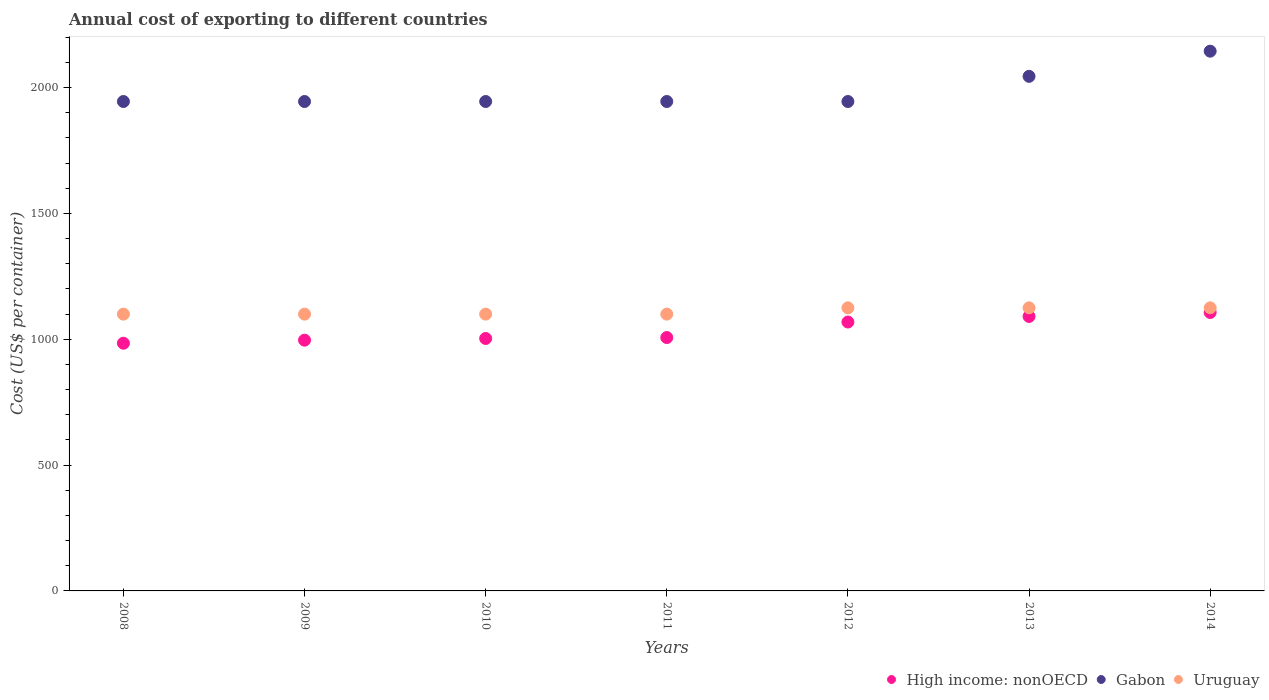Is the number of dotlines equal to the number of legend labels?
Your answer should be compact. Yes. What is the total annual cost of exporting in High income: nonOECD in 2010?
Provide a succinct answer. 1003.24. Across all years, what is the maximum total annual cost of exporting in High income: nonOECD?
Your response must be concise. 1106.62. Across all years, what is the minimum total annual cost of exporting in Uruguay?
Your answer should be very brief. 1100. What is the total total annual cost of exporting in High income: nonOECD in the graph?
Make the answer very short. 7257.19. What is the difference between the total annual cost of exporting in Uruguay in 2010 and that in 2013?
Offer a very short reply. -25. What is the difference between the total annual cost of exporting in High income: nonOECD in 2011 and the total annual cost of exporting in Gabon in 2012?
Offer a very short reply. -938.04. What is the average total annual cost of exporting in High income: nonOECD per year?
Give a very brief answer. 1036.74. In the year 2012, what is the difference between the total annual cost of exporting in High income: nonOECD and total annual cost of exporting in Gabon?
Keep it short and to the point. -876.36. In how many years, is the total annual cost of exporting in Uruguay greater than 2000 US$?
Give a very brief answer. 0. What is the ratio of the total annual cost of exporting in Gabon in 2008 to that in 2014?
Offer a very short reply. 0.91. What is the difference between the highest and the second highest total annual cost of exporting in High income: nonOECD?
Keep it short and to the point. 15.82. What is the difference between the highest and the lowest total annual cost of exporting in Uruguay?
Offer a terse response. 25. Is the sum of the total annual cost of exporting in Gabon in 2009 and 2010 greater than the maximum total annual cost of exporting in Uruguay across all years?
Ensure brevity in your answer.  Yes. Does the total annual cost of exporting in Uruguay monotonically increase over the years?
Keep it short and to the point. No. Is the total annual cost of exporting in High income: nonOECD strictly less than the total annual cost of exporting in Gabon over the years?
Provide a succinct answer. Yes. How many dotlines are there?
Offer a very short reply. 3. Are the values on the major ticks of Y-axis written in scientific E-notation?
Provide a short and direct response. No. Does the graph contain grids?
Keep it short and to the point. No. Where does the legend appear in the graph?
Make the answer very short. Bottom right. How are the legend labels stacked?
Provide a succinct answer. Horizontal. What is the title of the graph?
Give a very brief answer. Annual cost of exporting to different countries. What is the label or title of the Y-axis?
Provide a short and direct response. Cost (US$ per container). What is the Cost (US$ per container) in High income: nonOECD in 2008?
Provide a succinct answer. 984.4. What is the Cost (US$ per container) of Gabon in 2008?
Your answer should be compact. 1945. What is the Cost (US$ per container) in Uruguay in 2008?
Your answer should be compact. 1100. What is the Cost (US$ per container) of High income: nonOECD in 2009?
Offer a very short reply. 996.52. What is the Cost (US$ per container) in Gabon in 2009?
Give a very brief answer. 1945. What is the Cost (US$ per container) in Uruguay in 2009?
Make the answer very short. 1100. What is the Cost (US$ per container) in High income: nonOECD in 2010?
Offer a very short reply. 1003.24. What is the Cost (US$ per container) in Gabon in 2010?
Your answer should be very brief. 1945. What is the Cost (US$ per container) in Uruguay in 2010?
Your answer should be very brief. 1100. What is the Cost (US$ per container) of High income: nonOECD in 2011?
Your answer should be very brief. 1006.96. What is the Cost (US$ per container) in Gabon in 2011?
Keep it short and to the point. 1945. What is the Cost (US$ per container) in Uruguay in 2011?
Keep it short and to the point. 1100. What is the Cost (US$ per container) of High income: nonOECD in 2012?
Give a very brief answer. 1068.64. What is the Cost (US$ per container) of Gabon in 2012?
Provide a short and direct response. 1945. What is the Cost (US$ per container) in Uruguay in 2012?
Offer a very short reply. 1125. What is the Cost (US$ per container) of High income: nonOECD in 2013?
Keep it short and to the point. 1090.8. What is the Cost (US$ per container) of Gabon in 2013?
Your response must be concise. 2045. What is the Cost (US$ per container) of Uruguay in 2013?
Provide a short and direct response. 1125. What is the Cost (US$ per container) in High income: nonOECD in 2014?
Provide a succinct answer. 1106.62. What is the Cost (US$ per container) of Gabon in 2014?
Give a very brief answer. 2145. What is the Cost (US$ per container) in Uruguay in 2014?
Your answer should be very brief. 1125. Across all years, what is the maximum Cost (US$ per container) of High income: nonOECD?
Provide a succinct answer. 1106.62. Across all years, what is the maximum Cost (US$ per container) in Gabon?
Keep it short and to the point. 2145. Across all years, what is the maximum Cost (US$ per container) in Uruguay?
Ensure brevity in your answer.  1125. Across all years, what is the minimum Cost (US$ per container) in High income: nonOECD?
Offer a terse response. 984.4. Across all years, what is the minimum Cost (US$ per container) in Gabon?
Ensure brevity in your answer.  1945. Across all years, what is the minimum Cost (US$ per container) in Uruguay?
Your answer should be compact. 1100. What is the total Cost (US$ per container) in High income: nonOECD in the graph?
Your answer should be compact. 7257.19. What is the total Cost (US$ per container) in Gabon in the graph?
Your answer should be compact. 1.39e+04. What is the total Cost (US$ per container) in Uruguay in the graph?
Your answer should be compact. 7775. What is the difference between the Cost (US$ per container) of High income: nonOECD in 2008 and that in 2009?
Your answer should be very brief. -12.12. What is the difference between the Cost (US$ per container) of Gabon in 2008 and that in 2009?
Provide a short and direct response. 0. What is the difference between the Cost (US$ per container) of High income: nonOECD in 2008 and that in 2010?
Offer a very short reply. -18.84. What is the difference between the Cost (US$ per container) in Uruguay in 2008 and that in 2010?
Provide a short and direct response. 0. What is the difference between the Cost (US$ per container) in High income: nonOECD in 2008 and that in 2011?
Your response must be concise. -22.56. What is the difference between the Cost (US$ per container) in Uruguay in 2008 and that in 2011?
Make the answer very short. 0. What is the difference between the Cost (US$ per container) of High income: nonOECD in 2008 and that in 2012?
Provide a short and direct response. -84.24. What is the difference between the Cost (US$ per container) of Gabon in 2008 and that in 2012?
Provide a succinct answer. 0. What is the difference between the Cost (US$ per container) in Uruguay in 2008 and that in 2012?
Ensure brevity in your answer.  -25. What is the difference between the Cost (US$ per container) in High income: nonOECD in 2008 and that in 2013?
Your answer should be very brief. -106.4. What is the difference between the Cost (US$ per container) in Gabon in 2008 and that in 2013?
Your response must be concise. -100. What is the difference between the Cost (US$ per container) of Uruguay in 2008 and that in 2013?
Your answer should be very brief. -25. What is the difference between the Cost (US$ per container) of High income: nonOECD in 2008 and that in 2014?
Offer a very short reply. -122.22. What is the difference between the Cost (US$ per container) in Gabon in 2008 and that in 2014?
Your response must be concise. -200. What is the difference between the Cost (US$ per container) in Uruguay in 2008 and that in 2014?
Your response must be concise. -25. What is the difference between the Cost (US$ per container) of High income: nonOECD in 2009 and that in 2010?
Offer a terse response. -6.72. What is the difference between the Cost (US$ per container) of Gabon in 2009 and that in 2010?
Ensure brevity in your answer.  0. What is the difference between the Cost (US$ per container) of Uruguay in 2009 and that in 2010?
Your response must be concise. 0. What is the difference between the Cost (US$ per container) in High income: nonOECD in 2009 and that in 2011?
Your response must be concise. -10.44. What is the difference between the Cost (US$ per container) of Gabon in 2009 and that in 2011?
Ensure brevity in your answer.  0. What is the difference between the Cost (US$ per container) of Uruguay in 2009 and that in 2011?
Make the answer very short. 0. What is the difference between the Cost (US$ per container) in High income: nonOECD in 2009 and that in 2012?
Offer a very short reply. -72.12. What is the difference between the Cost (US$ per container) of Uruguay in 2009 and that in 2012?
Give a very brief answer. -25. What is the difference between the Cost (US$ per container) of High income: nonOECD in 2009 and that in 2013?
Ensure brevity in your answer.  -94.28. What is the difference between the Cost (US$ per container) of Gabon in 2009 and that in 2013?
Give a very brief answer. -100. What is the difference between the Cost (US$ per container) of High income: nonOECD in 2009 and that in 2014?
Provide a short and direct response. -110.11. What is the difference between the Cost (US$ per container) of Gabon in 2009 and that in 2014?
Ensure brevity in your answer.  -200. What is the difference between the Cost (US$ per container) in Uruguay in 2009 and that in 2014?
Your response must be concise. -25. What is the difference between the Cost (US$ per container) in High income: nonOECD in 2010 and that in 2011?
Make the answer very short. -3.72. What is the difference between the Cost (US$ per container) in Gabon in 2010 and that in 2011?
Your response must be concise. 0. What is the difference between the Cost (US$ per container) in High income: nonOECD in 2010 and that in 2012?
Give a very brief answer. -65.4. What is the difference between the Cost (US$ per container) in Gabon in 2010 and that in 2012?
Your answer should be compact. 0. What is the difference between the Cost (US$ per container) in High income: nonOECD in 2010 and that in 2013?
Offer a very short reply. -87.56. What is the difference between the Cost (US$ per container) in Gabon in 2010 and that in 2013?
Keep it short and to the point. -100. What is the difference between the Cost (US$ per container) in High income: nonOECD in 2010 and that in 2014?
Your answer should be very brief. -103.39. What is the difference between the Cost (US$ per container) in Gabon in 2010 and that in 2014?
Your response must be concise. -200. What is the difference between the Cost (US$ per container) in High income: nonOECD in 2011 and that in 2012?
Provide a short and direct response. -61.68. What is the difference between the Cost (US$ per container) in Gabon in 2011 and that in 2012?
Provide a succinct answer. 0. What is the difference between the Cost (US$ per container) in High income: nonOECD in 2011 and that in 2013?
Offer a very short reply. -83.84. What is the difference between the Cost (US$ per container) in Gabon in 2011 and that in 2013?
Provide a succinct answer. -100. What is the difference between the Cost (US$ per container) of Uruguay in 2011 and that in 2013?
Keep it short and to the point. -25. What is the difference between the Cost (US$ per container) in High income: nonOECD in 2011 and that in 2014?
Ensure brevity in your answer.  -99.66. What is the difference between the Cost (US$ per container) in Gabon in 2011 and that in 2014?
Provide a short and direct response. -200. What is the difference between the Cost (US$ per container) in High income: nonOECD in 2012 and that in 2013?
Ensure brevity in your answer.  -22.16. What is the difference between the Cost (US$ per container) of Gabon in 2012 and that in 2013?
Your response must be concise. -100. What is the difference between the Cost (US$ per container) in Uruguay in 2012 and that in 2013?
Keep it short and to the point. 0. What is the difference between the Cost (US$ per container) in High income: nonOECD in 2012 and that in 2014?
Ensure brevity in your answer.  -37.98. What is the difference between the Cost (US$ per container) in Gabon in 2012 and that in 2014?
Offer a very short reply. -200. What is the difference between the Cost (US$ per container) in Uruguay in 2012 and that in 2014?
Keep it short and to the point. 0. What is the difference between the Cost (US$ per container) of High income: nonOECD in 2013 and that in 2014?
Give a very brief answer. -15.82. What is the difference between the Cost (US$ per container) of Gabon in 2013 and that in 2014?
Provide a short and direct response. -100. What is the difference between the Cost (US$ per container) in High income: nonOECD in 2008 and the Cost (US$ per container) in Gabon in 2009?
Your answer should be compact. -960.6. What is the difference between the Cost (US$ per container) in High income: nonOECD in 2008 and the Cost (US$ per container) in Uruguay in 2009?
Ensure brevity in your answer.  -115.6. What is the difference between the Cost (US$ per container) in Gabon in 2008 and the Cost (US$ per container) in Uruguay in 2009?
Provide a succinct answer. 845. What is the difference between the Cost (US$ per container) of High income: nonOECD in 2008 and the Cost (US$ per container) of Gabon in 2010?
Offer a terse response. -960.6. What is the difference between the Cost (US$ per container) in High income: nonOECD in 2008 and the Cost (US$ per container) in Uruguay in 2010?
Give a very brief answer. -115.6. What is the difference between the Cost (US$ per container) of Gabon in 2008 and the Cost (US$ per container) of Uruguay in 2010?
Provide a succinct answer. 845. What is the difference between the Cost (US$ per container) of High income: nonOECD in 2008 and the Cost (US$ per container) of Gabon in 2011?
Ensure brevity in your answer.  -960.6. What is the difference between the Cost (US$ per container) in High income: nonOECD in 2008 and the Cost (US$ per container) in Uruguay in 2011?
Give a very brief answer. -115.6. What is the difference between the Cost (US$ per container) in Gabon in 2008 and the Cost (US$ per container) in Uruguay in 2011?
Make the answer very short. 845. What is the difference between the Cost (US$ per container) of High income: nonOECD in 2008 and the Cost (US$ per container) of Gabon in 2012?
Keep it short and to the point. -960.6. What is the difference between the Cost (US$ per container) of High income: nonOECD in 2008 and the Cost (US$ per container) of Uruguay in 2012?
Offer a very short reply. -140.6. What is the difference between the Cost (US$ per container) of Gabon in 2008 and the Cost (US$ per container) of Uruguay in 2012?
Your answer should be compact. 820. What is the difference between the Cost (US$ per container) of High income: nonOECD in 2008 and the Cost (US$ per container) of Gabon in 2013?
Provide a short and direct response. -1060.6. What is the difference between the Cost (US$ per container) in High income: nonOECD in 2008 and the Cost (US$ per container) in Uruguay in 2013?
Your answer should be compact. -140.6. What is the difference between the Cost (US$ per container) in Gabon in 2008 and the Cost (US$ per container) in Uruguay in 2013?
Your answer should be compact. 820. What is the difference between the Cost (US$ per container) of High income: nonOECD in 2008 and the Cost (US$ per container) of Gabon in 2014?
Provide a succinct answer. -1160.6. What is the difference between the Cost (US$ per container) of High income: nonOECD in 2008 and the Cost (US$ per container) of Uruguay in 2014?
Make the answer very short. -140.6. What is the difference between the Cost (US$ per container) in Gabon in 2008 and the Cost (US$ per container) in Uruguay in 2014?
Offer a terse response. 820. What is the difference between the Cost (US$ per container) in High income: nonOECD in 2009 and the Cost (US$ per container) in Gabon in 2010?
Offer a very short reply. -948.48. What is the difference between the Cost (US$ per container) of High income: nonOECD in 2009 and the Cost (US$ per container) of Uruguay in 2010?
Ensure brevity in your answer.  -103.48. What is the difference between the Cost (US$ per container) in Gabon in 2009 and the Cost (US$ per container) in Uruguay in 2010?
Keep it short and to the point. 845. What is the difference between the Cost (US$ per container) in High income: nonOECD in 2009 and the Cost (US$ per container) in Gabon in 2011?
Your response must be concise. -948.48. What is the difference between the Cost (US$ per container) of High income: nonOECD in 2009 and the Cost (US$ per container) of Uruguay in 2011?
Your answer should be compact. -103.48. What is the difference between the Cost (US$ per container) in Gabon in 2009 and the Cost (US$ per container) in Uruguay in 2011?
Your response must be concise. 845. What is the difference between the Cost (US$ per container) in High income: nonOECD in 2009 and the Cost (US$ per container) in Gabon in 2012?
Provide a succinct answer. -948.48. What is the difference between the Cost (US$ per container) of High income: nonOECD in 2009 and the Cost (US$ per container) of Uruguay in 2012?
Keep it short and to the point. -128.48. What is the difference between the Cost (US$ per container) in Gabon in 2009 and the Cost (US$ per container) in Uruguay in 2012?
Provide a short and direct response. 820. What is the difference between the Cost (US$ per container) of High income: nonOECD in 2009 and the Cost (US$ per container) of Gabon in 2013?
Provide a short and direct response. -1048.48. What is the difference between the Cost (US$ per container) in High income: nonOECD in 2009 and the Cost (US$ per container) in Uruguay in 2013?
Provide a short and direct response. -128.48. What is the difference between the Cost (US$ per container) in Gabon in 2009 and the Cost (US$ per container) in Uruguay in 2013?
Your answer should be very brief. 820. What is the difference between the Cost (US$ per container) in High income: nonOECD in 2009 and the Cost (US$ per container) in Gabon in 2014?
Offer a terse response. -1148.48. What is the difference between the Cost (US$ per container) of High income: nonOECD in 2009 and the Cost (US$ per container) of Uruguay in 2014?
Offer a very short reply. -128.48. What is the difference between the Cost (US$ per container) in Gabon in 2009 and the Cost (US$ per container) in Uruguay in 2014?
Make the answer very short. 820. What is the difference between the Cost (US$ per container) of High income: nonOECD in 2010 and the Cost (US$ per container) of Gabon in 2011?
Provide a succinct answer. -941.76. What is the difference between the Cost (US$ per container) in High income: nonOECD in 2010 and the Cost (US$ per container) in Uruguay in 2011?
Offer a very short reply. -96.76. What is the difference between the Cost (US$ per container) of Gabon in 2010 and the Cost (US$ per container) of Uruguay in 2011?
Your response must be concise. 845. What is the difference between the Cost (US$ per container) in High income: nonOECD in 2010 and the Cost (US$ per container) in Gabon in 2012?
Offer a terse response. -941.76. What is the difference between the Cost (US$ per container) of High income: nonOECD in 2010 and the Cost (US$ per container) of Uruguay in 2012?
Provide a succinct answer. -121.76. What is the difference between the Cost (US$ per container) of Gabon in 2010 and the Cost (US$ per container) of Uruguay in 2012?
Give a very brief answer. 820. What is the difference between the Cost (US$ per container) of High income: nonOECD in 2010 and the Cost (US$ per container) of Gabon in 2013?
Your answer should be very brief. -1041.76. What is the difference between the Cost (US$ per container) of High income: nonOECD in 2010 and the Cost (US$ per container) of Uruguay in 2013?
Your answer should be compact. -121.76. What is the difference between the Cost (US$ per container) of Gabon in 2010 and the Cost (US$ per container) of Uruguay in 2013?
Keep it short and to the point. 820. What is the difference between the Cost (US$ per container) in High income: nonOECD in 2010 and the Cost (US$ per container) in Gabon in 2014?
Give a very brief answer. -1141.76. What is the difference between the Cost (US$ per container) of High income: nonOECD in 2010 and the Cost (US$ per container) of Uruguay in 2014?
Keep it short and to the point. -121.76. What is the difference between the Cost (US$ per container) of Gabon in 2010 and the Cost (US$ per container) of Uruguay in 2014?
Your answer should be very brief. 820. What is the difference between the Cost (US$ per container) of High income: nonOECD in 2011 and the Cost (US$ per container) of Gabon in 2012?
Give a very brief answer. -938.04. What is the difference between the Cost (US$ per container) in High income: nonOECD in 2011 and the Cost (US$ per container) in Uruguay in 2012?
Your answer should be compact. -118.04. What is the difference between the Cost (US$ per container) of Gabon in 2011 and the Cost (US$ per container) of Uruguay in 2012?
Give a very brief answer. 820. What is the difference between the Cost (US$ per container) in High income: nonOECD in 2011 and the Cost (US$ per container) in Gabon in 2013?
Your answer should be very brief. -1038.04. What is the difference between the Cost (US$ per container) in High income: nonOECD in 2011 and the Cost (US$ per container) in Uruguay in 2013?
Your answer should be very brief. -118.04. What is the difference between the Cost (US$ per container) in Gabon in 2011 and the Cost (US$ per container) in Uruguay in 2013?
Make the answer very short. 820. What is the difference between the Cost (US$ per container) of High income: nonOECD in 2011 and the Cost (US$ per container) of Gabon in 2014?
Offer a terse response. -1138.04. What is the difference between the Cost (US$ per container) of High income: nonOECD in 2011 and the Cost (US$ per container) of Uruguay in 2014?
Make the answer very short. -118.04. What is the difference between the Cost (US$ per container) of Gabon in 2011 and the Cost (US$ per container) of Uruguay in 2014?
Ensure brevity in your answer.  820. What is the difference between the Cost (US$ per container) of High income: nonOECD in 2012 and the Cost (US$ per container) of Gabon in 2013?
Ensure brevity in your answer.  -976.36. What is the difference between the Cost (US$ per container) in High income: nonOECD in 2012 and the Cost (US$ per container) in Uruguay in 2013?
Make the answer very short. -56.36. What is the difference between the Cost (US$ per container) of Gabon in 2012 and the Cost (US$ per container) of Uruguay in 2013?
Your answer should be compact. 820. What is the difference between the Cost (US$ per container) of High income: nonOECD in 2012 and the Cost (US$ per container) of Gabon in 2014?
Keep it short and to the point. -1076.36. What is the difference between the Cost (US$ per container) in High income: nonOECD in 2012 and the Cost (US$ per container) in Uruguay in 2014?
Offer a terse response. -56.36. What is the difference between the Cost (US$ per container) of Gabon in 2012 and the Cost (US$ per container) of Uruguay in 2014?
Offer a terse response. 820. What is the difference between the Cost (US$ per container) of High income: nonOECD in 2013 and the Cost (US$ per container) of Gabon in 2014?
Your answer should be compact. -1054.2. What is the difference between the Cost (US$ per container) in High income: nonOECD in 2013 and the Cost (US$ per container) in Uruguay in 2014?
Provide a short and direct response. -34.2. What is the difference between the Cost (US$ per container) in Gabon in 2013 and the Cost (US$ per container) in Uruguay in 2014?
Offer a very short reply. 920. What is the average Cost (US$ per container) of High income: nonOECD per year?
Give a very brief answer. 1036.74. What is the average Cost (US$ per container) of Gabon per year?
Offer a very short reply. 1987.86. What is the average Cost (US$ per container) of Uruguay per year?
Keep it short and to the point. 1110.71. In the year 2008, what is the difference between the Cost (US$ per container) of High income: nonOECD and Cost (US$ per container) of Gabon?
Keep it short and to the point. -960.6. In the year 2008, what is the difference between the Cost (US$ per container) in High income: nonOECD and Cost (US$ per container) in Uruguay?
Your answer should be very brief. -115.6. In the year 2008, what is the difference between the Cost (US$ per container) in Gabon and Cost (US$ per container) in Uruguay?
Provide a succinct answer. 845. In the year 2009, what is the difference between the Cost (US$ per container) of High income: nonOECD and Cost (US$ per container) of Gabon?
Offer a very short reply. -948.48. In the year 2009, what is the difference between the Cost (US$ per container) of High income: nonOECD and Cost (US$ per container) of Uruguay?
Keep it short and to the point. -103.48. In the year 2009, what is the difference between the Cost (US$ per container) of Gabon and Cost (US$ per container) of Uruguay?
Keep it short and to the point. 845. In the year 2010, what is the difference between the Cost (US$ per container) of High income: nonOECD and Cost (US$ per container) of Gabon?
Ensure brevity in your answer.  -941.76. In the year 2010, what is the difference between the Cost (US$ per container) in High income: nonOECD and Cost (US$ per container) in Uruguay?
Give a very brief answer. -96.76. In the year 2010, what is the difference between the Cost (US$ per container) of Gabon and Cost (US$ per container) of Uruguay?
Provide a succinct answer. 845. In the year 2011, what is the difference between the Cost (US$ per container) of High income: nonOECD and Cost (US$ per container) of Gabon?
Your answer should be very brief. -938.04. In the year 2011, what is the difference between the Cost (US$ per container) of High income: nonOECD and Cost (US$ per container) of Uruguay?
Make the answer very short. -93.04. In the year 2011, what is the difference between the Cost (US$ per container) in Gabon and Cost (US$ per container) in Uruguay?
Your answer should be compact. 845. In the year 2012, what is the difference between the Cost (US$ per container) in High income: nonOECD and Cost (US$ per container) in Gabon?
Your answer should be compact. -876.36. In the year 2012, what is the difference between the Cost (US$ per container) in High income: nonOECD and Cost (US$ per container) in Uruguay?
Keep it short and to the point. -56.36. In the year 2012, what is the difference between the Cost (US$ per container) of Gabon and Cost (US$ per container) of Uruguay?
Keep it short and to the point. 820. In the year 2013, what is the difference between the Cost (US$ per container) of High income: nonOECD and Cost (US$ per container) of Gabon?
Your answer should be very brief. -954.2. In the year 2013, what is the difference between the Cost (US$ per container) in High income: nonOECD and Cost (US$ per container) in Uruguay?
Provide a succinct answer. -34.2. In the year 2013, what is the difference between the Cost (US$ per container) of Gabon and Cost (US$ per container) of Uruguay?
Provide a succinct answer. 920. In the year 2014, what is the difference between the Cost (US$ per container) of High income: nonOECD and Cost (US$ per container) of Gabon?
Offer a very short reply. -1038.38. In the year 2014, what is the difference between the Cost (US$ per container) in High income: nonOECD and Cost (US$ per container) in Uruguay?
Your answer should be compact. -18.38. In the year 2014, what is the difference between the Cost (US$ per container) in Gabon and Cost (US$ per container) in Uruguay?
Make the answer very short. 1020. What is the ratio of the Cost (US$ per container) in Gabon in 2008 to that in 2009?
Keep it short and to the point. 1. What is the ratio of the Cost (US$ per container) of Uruguay in 2008 to that in 2009?
Your answer should be compact. 1. What is the ratio of the Cost (US$ per container) of High income: nonOECD in 2008 to that in 2010?
Keep it short and to the point. 0.98. What is the ratio of the Cost (US$ per container) in Uruguay in 2008 to that in 2010?
Keep it short and to the point. 1. What is the ratio of the Cost (US$ per container) in High income: nonOECD in 2008 to that in 2011?
Keep it short and to the point. 0.98. What is the ratio of the Cost (US$ per container) of Gabon in 2008 to that in 2011?
Your answer should be very brief. 1. What is the ratio of the Cost (US$ per container) in High income: nonOECD in 2008 to that in 2012?
Your answer should be compact. 0.92. What is the ratio of the Cost (US$ per container) in Uruguay in 2008 to that in 2012?
Offer a very short reply. 0.98. What is the ratio of the Cost (US$ per container) of High income: nonOECD in 2008 to that in 2013?
Make the answer very short. 0.9. What is the ratio of the Cost (US$ per container) of Gabon in 2008 to that in 2013?
Offer a very short reply. 0.95. What is the ratio of the Cost (US$ per container) in Uruguay in 2008 to that in 2013?
Give a very brief answer. 0.98. What is the ratio of the Cost (US$ per container) of High income: nonOECD in 2008 to that in 2014?
Make the answer very short. 0.89. What is the ratio of the Cost (US$ per container) of Gabon in 2008 to that in 2014?
Ensure brevity in your answer.  0.91. What is the ratio of the Cost (US$ per container) in Uruguay in 2008 to that in 2014?
Provide a succinct answer. 0.98. What is the ratio of the Cost (US$ per container) of High income: nonOECD in 2009 to that in 2010?
Offer a very short reply. 0.99. What is the ratio of the Cost (US$ per container) of High income: nonOECD in 2009 to that in 2011?
Provide a short and direct response. 0.99. What is the ratio of the Cost (US$ per container) of High income: nonOECD in 2009 to that in 2012?
Offer a very short reply. 0.93. What is the ratio of the Cost (US$ per container) in Uruguay in 2009 to that in 2012?
Make the answer very short. 0.98. What is the ratio of the Cost (US$ per container) in High income: nonOECD in 2009 to that in 2013?
Make the answer very short. 0.91. What is the ratio of the Cost (US$ per container) of Gabon in 2009 to that in 2013?
Offer a very short reply. 0.95. What is the ratio of the Cost (US$ per container) of Uruguay in 2009 to that in 2013?
Give a very brief answer. 0.98. What is the ratio of the Cost (US$ per container) in High income: nonOECD in 2009 to that in 2014?
Offer a very short reply. 0.9. What is the ratio of the Cost (US$ per container) in Gabon in 2009 to that in 2014?
Your response must be concise. 0.91. What is the ratio of the Cost (US$ per container) of Uruguay in 2009 to that in 2014?
Keep it short and to the point. 0.98. What is the ratio of the Cost (US$ per container) in High income: nonOECD in 2010 to that in 2011?
Provide a succinct answer. 1. What is the ratio of the Cost (US$ per container) of High income: nonOECD in 2010 to that in 2012?
Provide a short and direct response. 0.94. What is the ratio of the Cost (US$ per container) of Gabon in 2010 to that in 2012?
Your response must be concise. 1. What is the ratio of the Cost (US$ per container) in Uruguay in 2010 to that in 2012?
Provide a short and direct response. 0.98. What is the ratio of the Cost (US$ per container) of High income: nonOECD in 2010 to that in 2013?
Offer a terse response. 0.92. What is the ratio of the Cost (US$ per container) of Gabon in 2010 to that in 2013?
Make the answer very short. 0.95. What is the ratio of the Cost (US$ per container) in Uruguay in 2010 to that in 2013?
Provide a succinct answer. 0.98. What is the ratio of the Cost (US$ per container) in High income: nonOECD in 2010 to that in 2014?
Offer a very short reply. 0.91. What is the ratio of the Cost (US$ per container) in Gabon in 2010 to that in 2014?
Provide a short and direct response. 0.91. What is the ratio of the Cost (US$ per container) in Uruguay in 2010 to that in 2014?
Provide a succinct answer. 0.98. What is the ratio of the Cost (US$ per container) of High income: nonOECD in 2011 to that in 2012?
Keep it short and to the point. 0.94. What is the ratio of the Cost (US$ per container) in Gabon in 2011 to that in 2012?
Offer a terse response. 1. What is the ratio of the Cost (US$ per container) in Uruguay in 2011 to that in 2012?
Offer a terse response. 0.98. What is the ratio of the Cost (US$ per container) in High income: nonOECD in 2011 to that in 2013?
Provide a short and direct response. 0.92. What is the ratio of the Cost (US$ per container) in Gabon in 2011 to that in 2013?
Provide a succinct answer. 0.95. What is the ratio of the Cost (US$ per container) of Uruguay in 2011 to that in 2013?
Your answer should be compact. 0.98. What is the ratio of the Cost (US$ per container) in High income: nonOECD in 2011 to that in 2014?
Make the answer very short. 0.91. What is the ratio of the Cost (US$ per container) of Gabon in 2011 to that in 2014?
Make the answer very short. 0.91. What is the ratio of the Cost (US$ per container) of Uruguay in 2011 to that in 2014?
Give a very brief answer. 0.98. What is the ratio of the Cost (US$ per container) in High income: nonOECD in 2012 to that in 2013?
Give a very brief answer. 0.98. What is the ratio of the Cost (US$ per container) in Gabon in 2012 to that in 2013?
Offer a terse response. 0.95. What is the ratio of the Cost (US$ per container) of Uruguay in 2012 to that in 2013?
Provide a short and direct response. 1. What is the ratio of the Cost (US$ per container) of High income: nonOECD in 2012 to that in 2014?
Your response must be concise. 0.97. What is the ratio of the Cost (US$ per container) in Gabon in 2012 to that in 2014?
Make the answer very short. 0.91. What is the ratio of the Cost (US$ per container) in High income: nonOECD in 2013 to that in 2014?
Provide a short and direct response. 0.99. What is the ratio of the Cost (US$ per container) of Gabon in 2013 to that in 2014?
Give a very brief answer. 0.95. What is the difference between the highest and the second highest Cost (US$ per container) in High income: nonOECD?
Ensure brevity in your answer.  15.82. What is the difference between the highest and the second highest Cost (US$ per container) in Gabon?
Your response must be concise. 100. What is the difference between the highest and the second highest Cost (US$ per container) of Uruguay?
Keep it short and to the point. 0. What is the difference between the highest and the lowest Cost (US$ per container) in High income: nonOECD?
Ensure brevity in your answer.  122.22. 